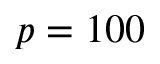<formula> <loc_0><loc_0><loc_500><loc_500>p = 1 0 0</formula> 